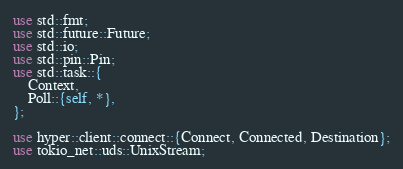Convert code to text. <code><loc_0><loc_0><loc_500><loc_500><_Rust_>use std::fmt;
use std::future::Future;
use std::io;
use std::pin::Pin;
use std::task::{
    Context,
    Poll::{self, *},
};

use hyper::client::connect::{Connect, Connected, Destination};
use tokio_net::uds::UnixStream;
</code> 